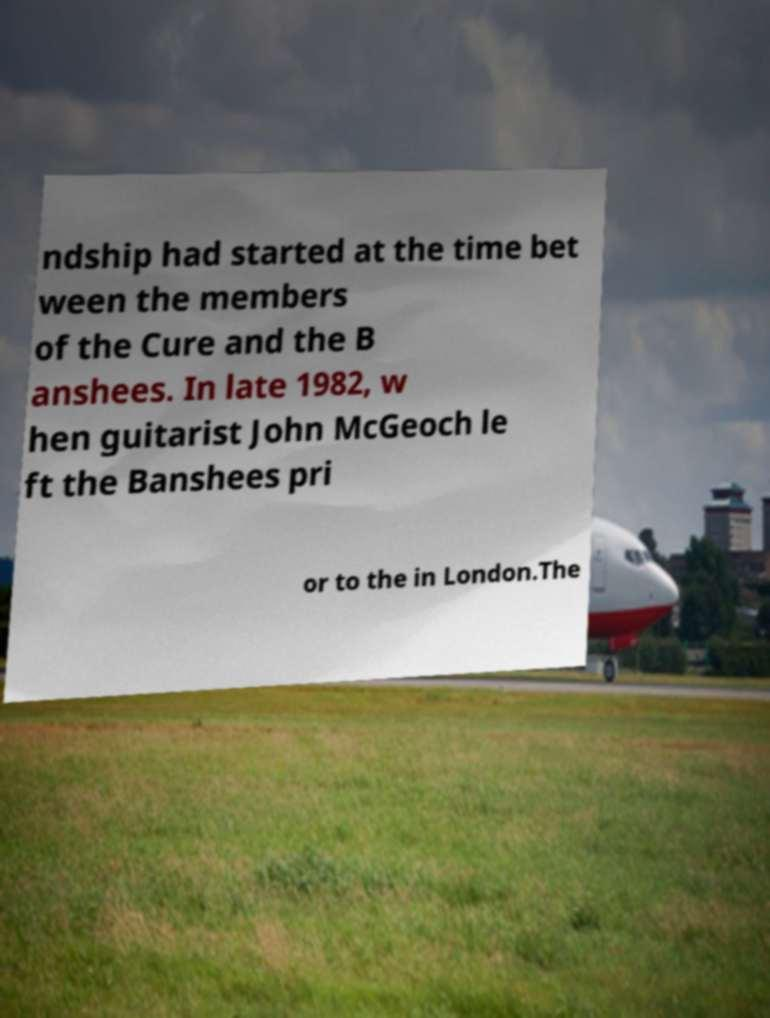For documentation purposes, I need the text within this image transcribed. Could you provide that? ndship had started at the time bet ween the members of the Cure and the B anshees. In late 1982, w hen guitarist John McGeoch le ft the Banshees pri or to the in London.The 